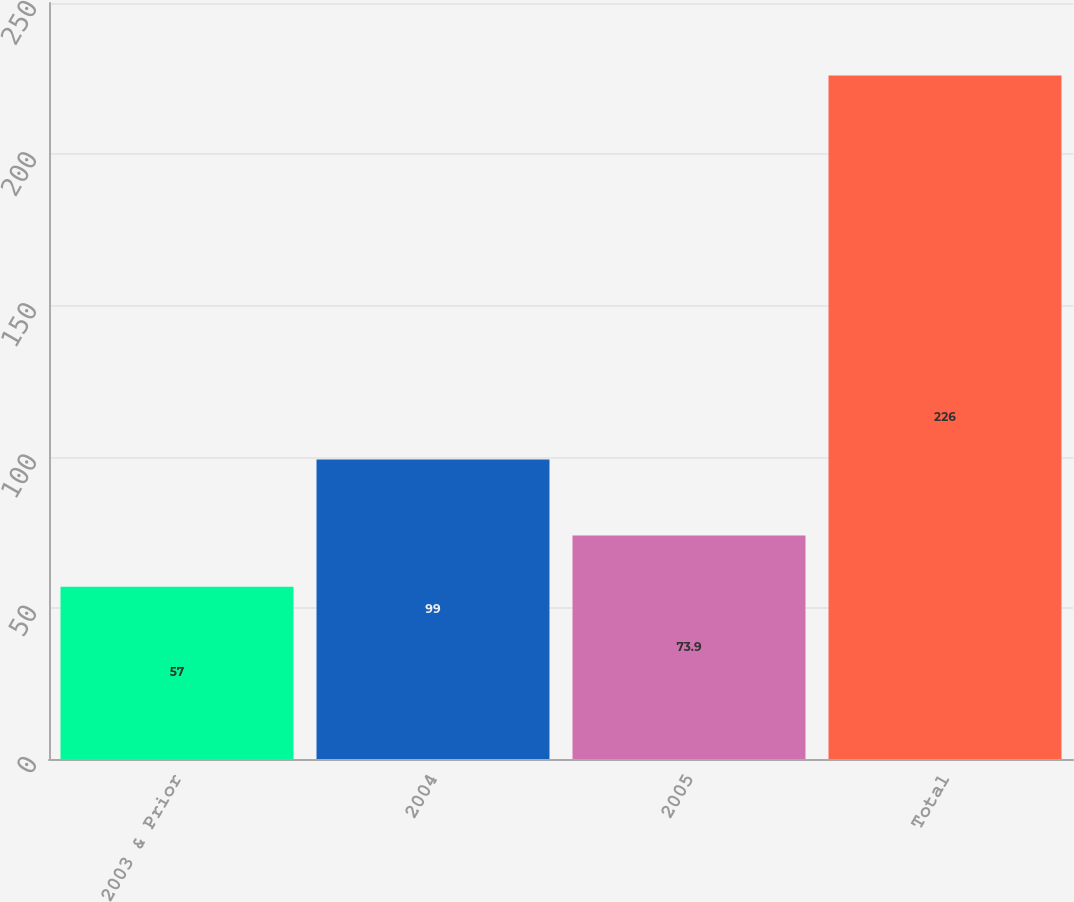Convert chart to OTSL. <chart><loc_0><loc_0><loc_500><loc_500><bar_chart><fcel>2003 & Prior<fcel>2004<fcel>2005<fcel>Total<nl><fcel>57<fcel>99<fcel>73.9<fcel>226<nl></chart> 